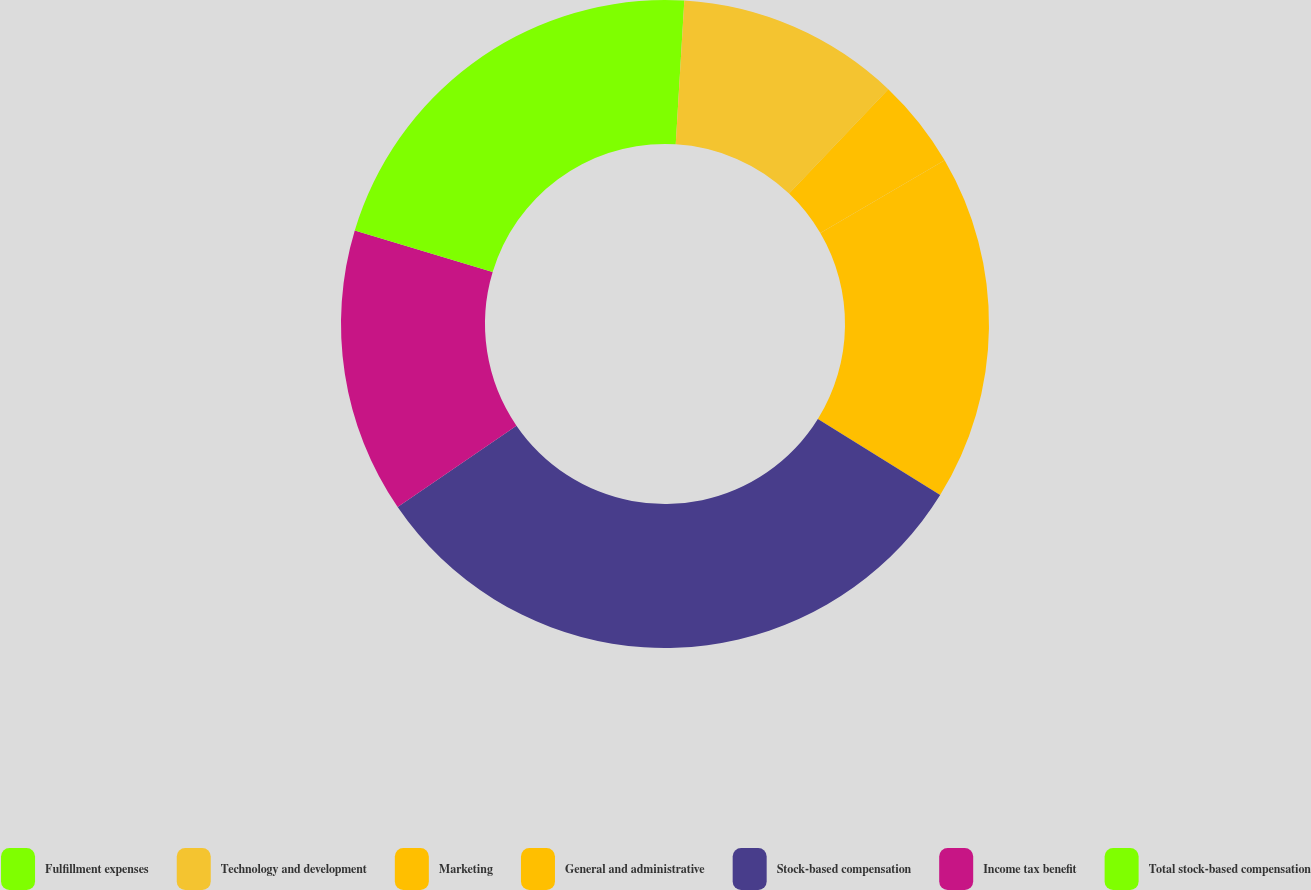<chart> <loc_0><loc_0><loc_500><loc_500><pie_chart><fcel>Fulfillment expenses<fcel>Technology and development<fcel>Marketing<fcel>General and administrative<fcel>Stock-based compensation<fcel>Income tax benefit<fcel>Total stock-based compensation<nl><fcel>0.95%<fcel>11.15%<fcel>4.47%<fcel>17.28%<fcel>31.59%<fcel>14.21%<fcel>20.34%<nl></chart> 